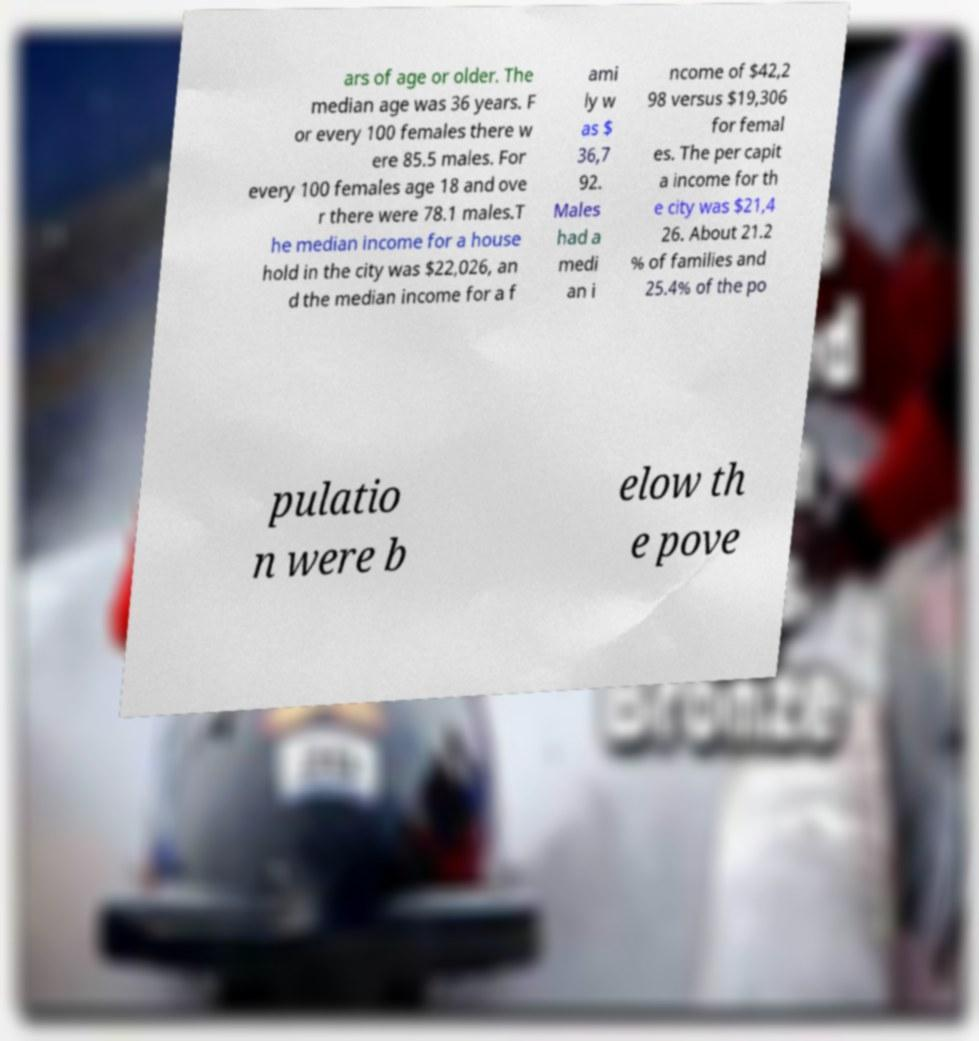What messages or text are displayed in this image? I need them in a readable, typed format. ars of age or older. The median age was 36 years. F or every 100 females there w ere 85.5 males. For every 100 females age 18 and ove r there were 78.1 males.T he median income for a house hold in the city was $22,026, an d the median income for a f ami ly w as $ 36,7 92. Males had a medi an i ncome of $42,2 98 versus $19,306 for femal es. The per capit a income for th e city was $21,4 26. About 21.2 % of families and 25.4% of the po pulatio n were b elow th e pove 